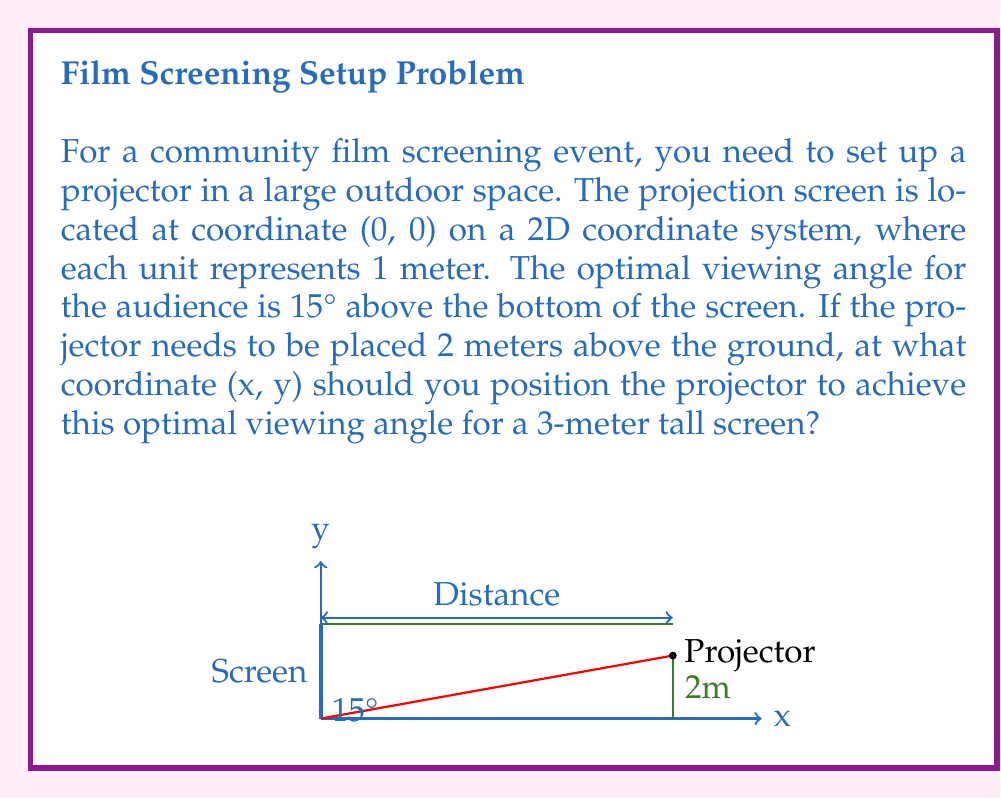Help me with this question. Let's approach this step-by-step:

1) First, we need to understand what the 15° angle means. It's the angle between the horizontal line from the bottom of the screen to the projector and the line from the bottom of the screen to the top of the screen.

2) We can create a right triangle with the following sides:
   - The height of the screen (3m) as the opposite side
   - The distance from the screen to the projector (which we'll call x) as the adjacent side
   - The hypotenuse is the line from the top of the screen to the projector

3) We can use the tangent function to relate the angle to the sides of this triangle:

   $$\tan(15°) = \frac{\text{opposite}}{\text{adjacent}} = \frac{3}{x}$$

4) Solve for x:

   $$x = \frac{3}{\tan(15°)} \approx 11.18\text{ meters}$$

5) Now we know the x-coordinate of the projector. For the y-coordinate, we simply use the given height of 2 meters.

6) Therefore, the coordinates of the projector should be approximately (11.18, 2).

7) We can verify this by calculating the angle:

   $$\tan^{-1}(\frac{3}{11.18}) \approx 15°$$

This confirms our calculation is correct.
Answer: (11.18, 2) 